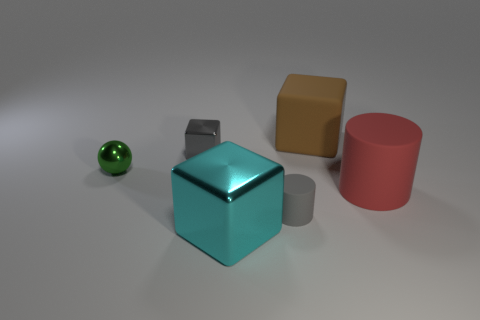What number of red matte cylinders are there?
Provide a short and direct response. 1. How many things are shiny things that are to the left of the big shiny cube or big cylinders?
Your response must be concise. 3. Do the large thing that is to the left of the small matte thing and the large cylinder have the same color?
Make the answer very short. No. What number of other objects are the same color as the tiny matte thing?
Offer a terse response. 1. What number of large things are either cyan rubber things or green shiny objects?
Provide a short and direct response. 0. Are there more big cyan metallic things than yellow metallic spheres?
Offer a terse response. Yes. Do the small green ball and the gray cylinder have the same material?
Your answer should be very brief. No. Are there any other things that are the same material as the green object?
Provide a succinct answer. Yes. Is the number of blocks that are in front of the gray matte cylinder greater than the number of large brown rubber cubes?
Provide a short and direct response. No. Do the small metal ball and the tiny metal cube have the same color?
Your answer should be compact. No. 